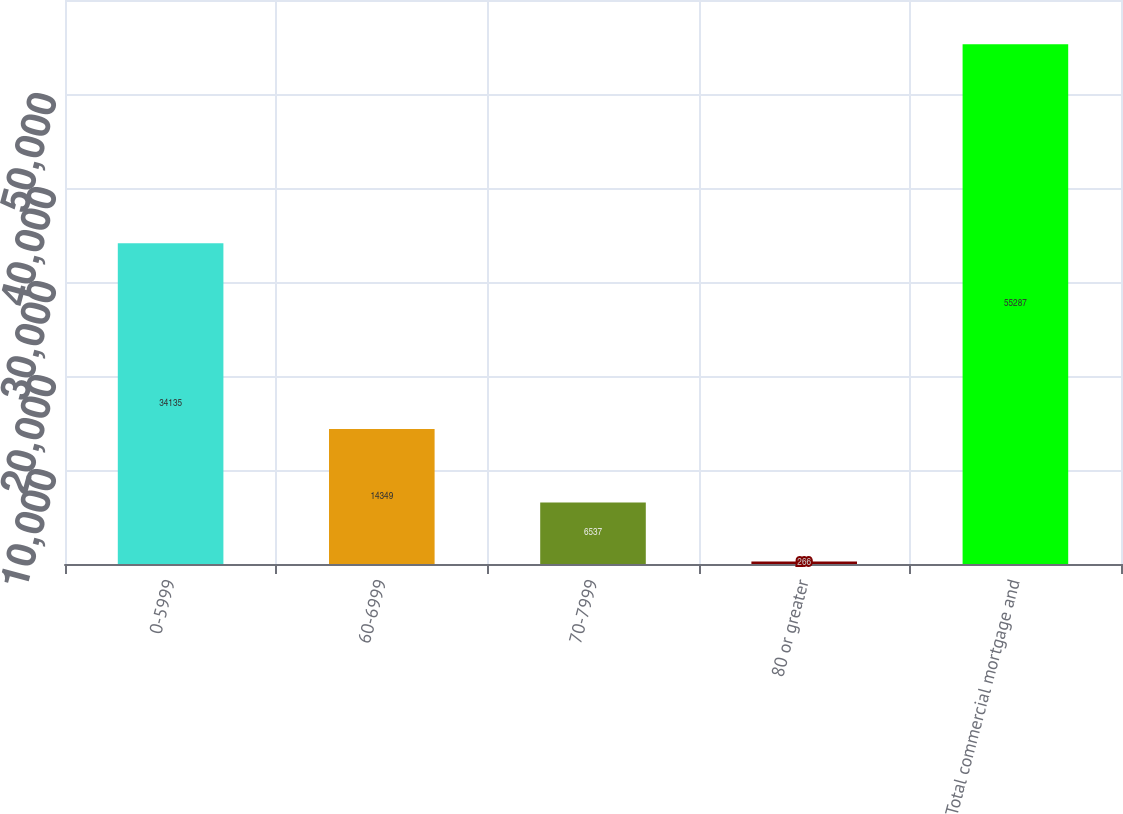<chart> <loc_0><loc_0><loc_500><loc_500><bar_chart><fcel>0-5999<fcel>60-6999<fcel>70-7999<fcel>80 or greater<fcel>Total commercial mortgage and<nl><fcel>34135<fcel>14349<fcel>6537<fcel>266<fcel>55287<nl></chart> 